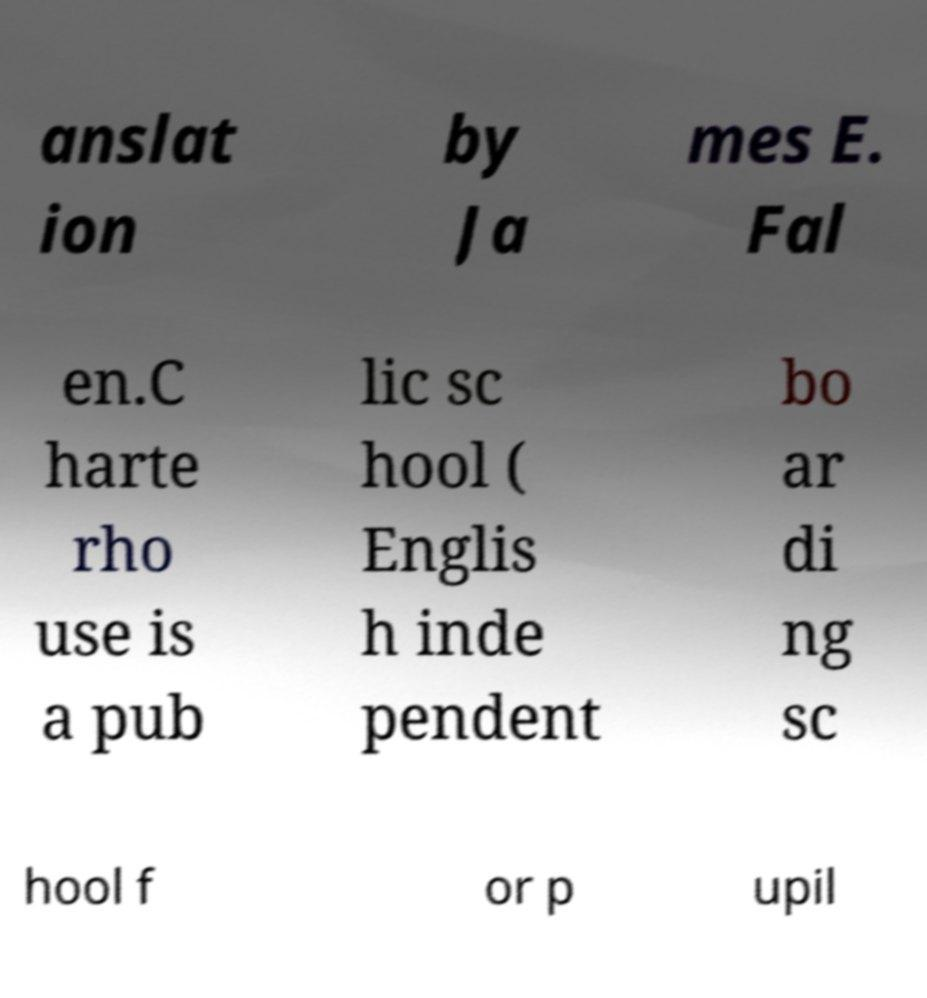For documentation purposes, I need the text within this image transcribed. Could you provide that? anslat ion by Ja mes E. Fal en.C harte rho use is a pub lic sc hool ( Englis h inde pendent bo ar di ng sc hool f or p upil 